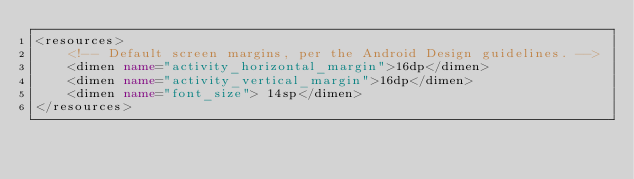<code> <loc_0><loc_0><loc_500><loc_500><_XML_><resources>
    <!-- Default screen margins, per the Android Design guidelines. -->
    <dimen name="activity_horizontal_margin">16dp</dimen>
    <dimen name="activity_vertical_margin">16dp</dimen>
    <dimen name="font_size"> 14sp</dimen>
</resources>
</code> 